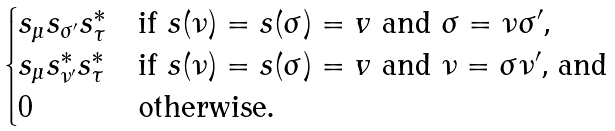Convert formula to latex. <formula><loc_0><loc_0><loc_500><loc_500>\begin{cases} s _ { \mu } s _ { \sigma ^ { \prime } } s _ { \tau } ^ { * } & \text {if $s(\nu)=s(\sigma)=v$ and $\sigma=\nu\sigma^{\prime}$,} \\ s _ { \mu } s _ { \nu ^ { \prime } } ^ { * } s _ { \tau } ^ { * } & \text {if $s(\nu)=s(\sigma)=v$ and $\nu=\sigma\nu^{\prime}$, and} \\ 0 & \text {otherwise.} \end{cases}</formula> 